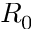Convert formula to latex. <formula><loc_0><loc_0><loc_500><loc_500>R _ { 0 }</formula> 